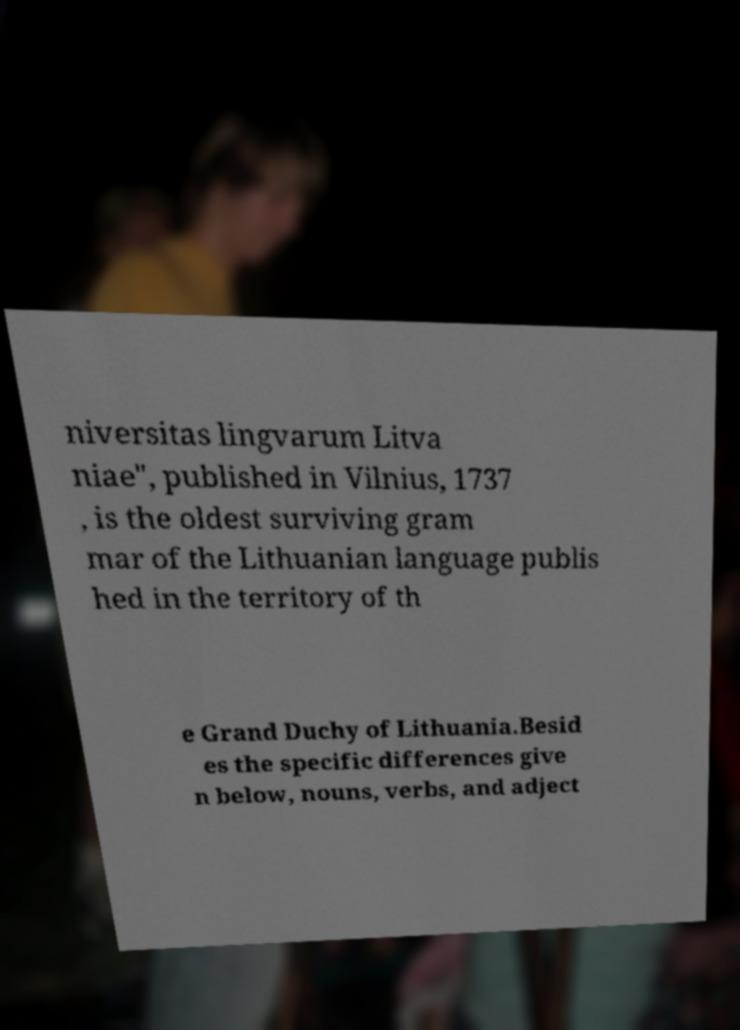I need the written content from this picture converted into text. Can you do that? niversitas lingvarum Litva niae", published in Vilnius, 1737 , is the oldest surviving gram mar of the Lithuanian language publis hed in the territory of th e Grand Duchy of Lithuania.Besid es the specific differences give n below, nouns, verbs, and adject 